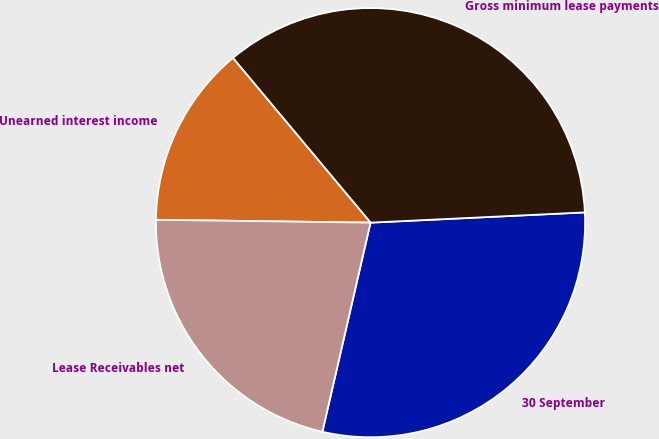Convert chart. <chart><loc_0><loc_0><loc_500><loc_500><pie_chart><fcel>30 September<fcel>Gross minimum lease payments<fcel>Unearned interest income<fcel>Lease Receivables net<nl><fcel>29.36%<fcel>35.32%<fcel>13.71%<fcel>21.61%<nl></chart> 